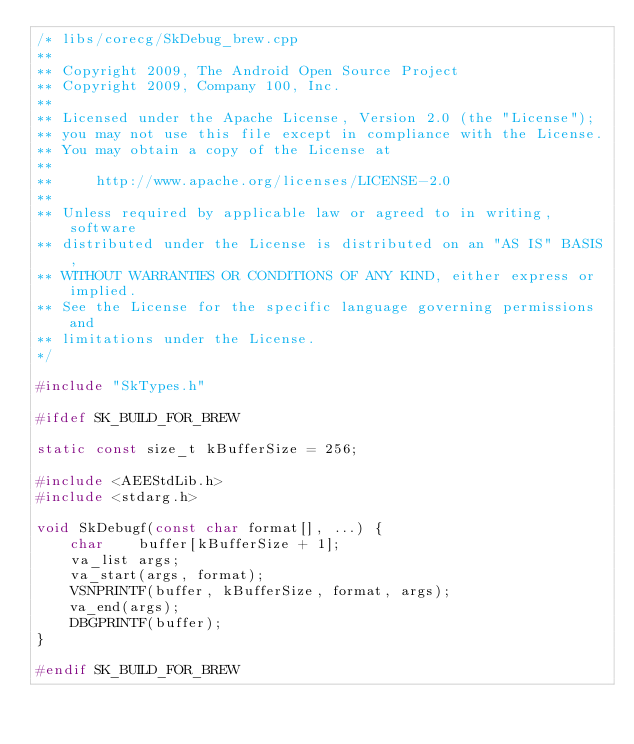<code> <loc_0><loc_0><loc_500><loc_500><_C++_>/* libs/corecg/SkDebug_brew.cpp
**
** Copyright 2009, The Android Open Source Project
** Copyright 2009, Company 100, Inc.
**
** Licensed under the Apache License, Version 2.0 (the "License"); 
** you may not use this file except in compliance with the License. 
** You may obtain a copy of the License at 
**
**     http://www.apache.org/licenses/LICENSE-2.0 
**
** Unless required by applicable law or agreed to in writing, software 
** distributed under the License is distributed on an "AS IS" BASIS, 
** WITHOUT WARRANTIES OR CONDITIONS OF ANY KIND, either express or implied. 
** See the License for the specific language governing permissions and 
** limitations under the License.
*/

#include "SkTypes.h"

#ifdef SK_BUILD_FOR_BREW

static const size_t kBufferSize = 256;

#include <AEEStdLib.h>
#include <stdarg.h>

void SkDebugf(const char format[], ...) {
    char    buffer[kBufferSize + 1];
    va_list args;
    va_start(args, format);
    VSNPRINTF(buffer, kBufferSize, format, args);
    va_end(args);
    DBGPRINTF(buffer);
}

#endif SK_BUILD_FOR_BREW
</code> 